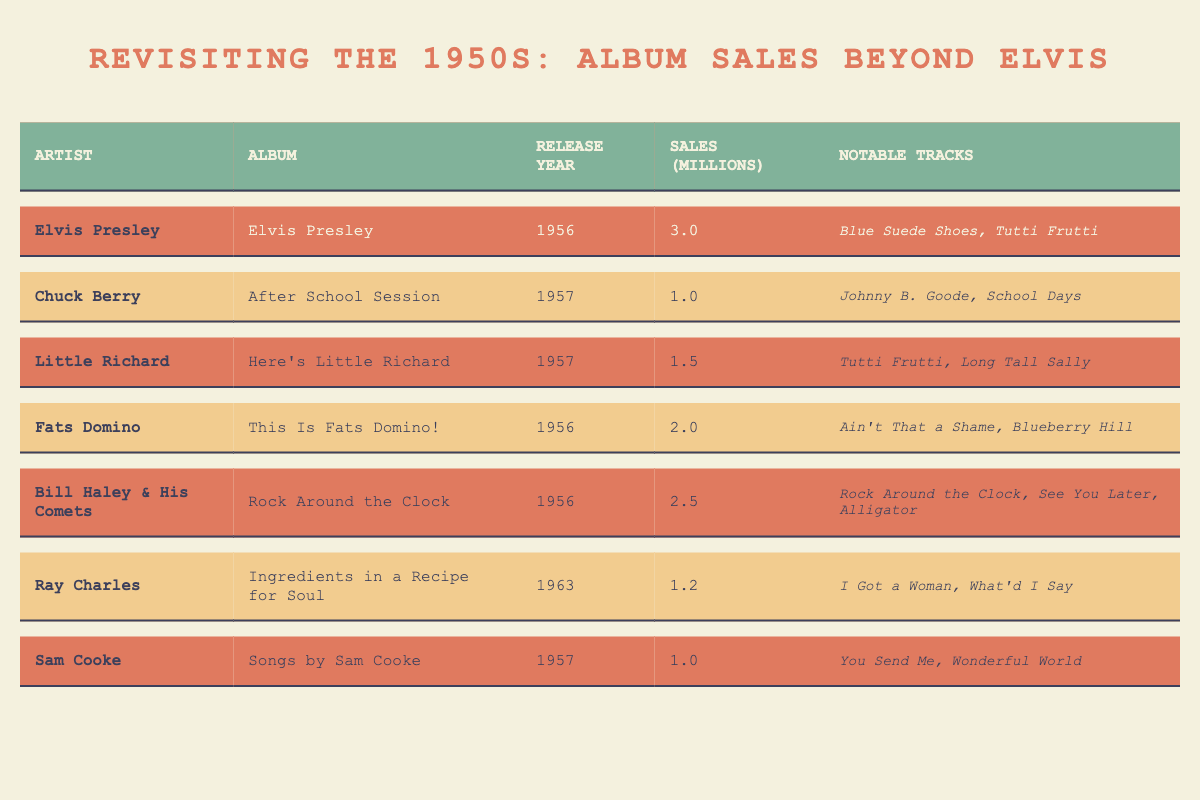What is the highest album sales in millions? By looking at the sales column in the table, the highest value is associated with Elvis Presley’s album "Elvis Presley" with 3.0 million sales.
Answer: 3.0 Which artist had album sales of 1.0 million? The table lists Chuck Berry and Sam Cooke, both with album sales of 1.0 million.
Answer: Chuck Berry and Sam Cooke What is the total album sales of albums released in 1956? The sales for albums released in 1956 are: Elvis Presley (3.0), Fats Domino (2.0), and Bill Haley & His Comets (2.5). Thus, the total is 3.0 + 2.0 + 2.5 = 7.5 million.
Answer: 7.5 How many notable tracks does the album by Little Richard have? The table shows that the album "Here's Little Richard" has 2 notable tracks: “Tutti Frutti” and “Long Tall Sally”.
Answer: 2 Who had more album sales, Fats Domino or Chuck Berry? Fats Domino had 2.0 million sales while Chuck Berry had 1.0 million. Therefore, Fats Domino had more sales.
Answer: Fats Domino What percentage of Elvis Presley's sales does Bill Haley & His Comets' sales represent? Elvis Presley has 3.0 million and Bill Haley & His Comets has 2.5 million. The percentage is calculated as (2.5 / 3.0) * 100 = 83.33%.
Answer: 83.33% Which artist's notable tracks include "Johnny B. Goode"? The notable track "Johnny B. Goode" belongs to Chuck Berry's album "After School Session."
Answer: Chuck Berry If we exclude Elvis Presley, what is the average album sales of the other artists in the table? The album sales excluding Elvis are: Chuck Berry (1.0), Little Richard (1.5), Fats Domino (2.0), Bill Haley & His Comets (2.5), Ray Charles (1.2), and Sam Cooke (1.0). Summing these gives 1.0 + 1.5 + 2.0 + 2.5 + 1.2 + 1.0 = 9.2 million, and there are 6 artists, so the average is 9.2 / 6 = 1.53 million.
Answer: 1.53 Is there any artist who had greater album sales than Fats Domino? Yes, Elvis Presley with 3.0 million and Bill Haley & His Comets with 2.5 million had greater album sales than Fats Domino.
Answer: Yes What was the release year of Elvis Presley's album? According to the table, Elvis Presley's album was released in 1956.
Answer: 1956 